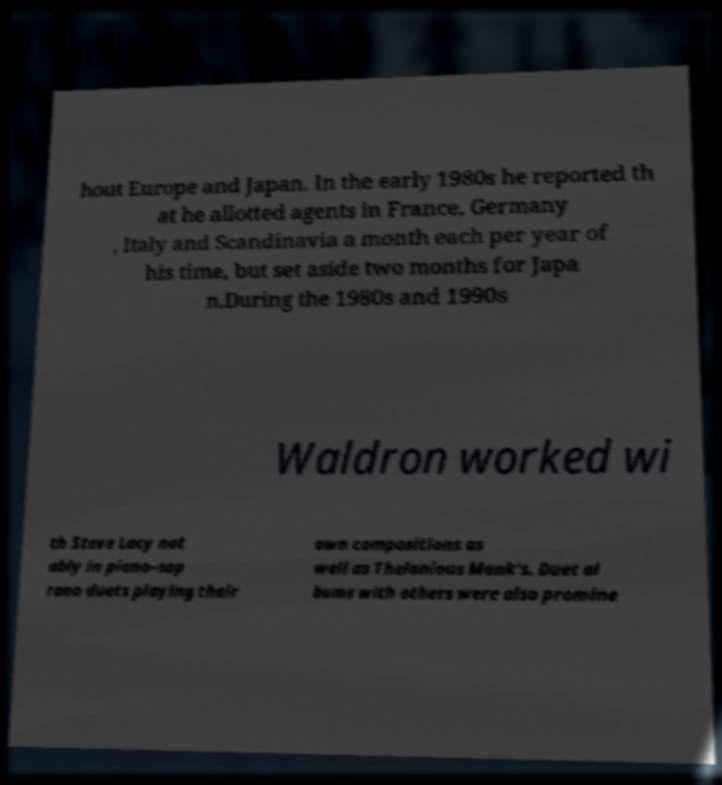For documentation purposes, I need the text within this image transcribed. Could you provide that? hout Europe and Japan. In the early 1980s he reported th at he allotted agents in France, Germany , Italy and Scandinavia a month each per year of his time, but set aside two months for Japa n.During the 1980s and 1990s Waldron worked wi th Steve Lacy not ably in piano–sop rano duets playing their own compositions as well as Thelonious Monk's. Duet al bums with others were also promine 